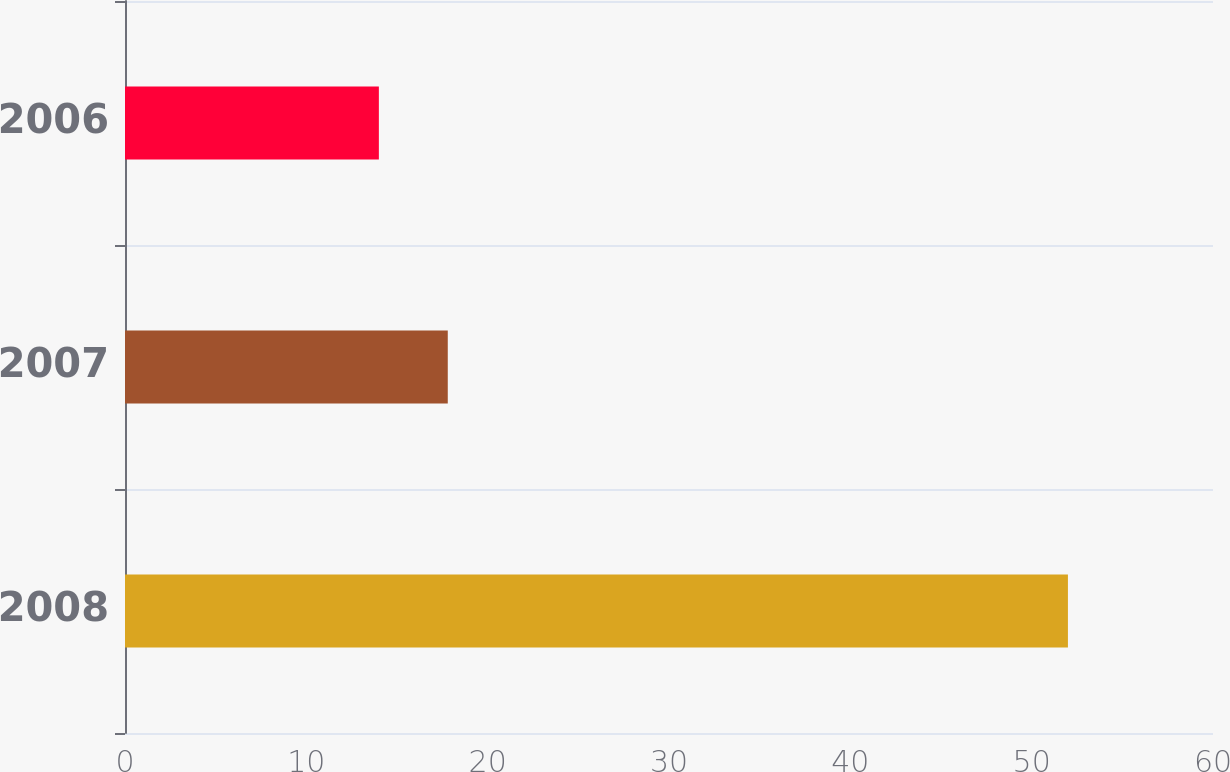Convert chart. <chart><loc_0><loc_0><loc_500><loc_500><bar_chart><fcel>2008<fcel>2007<fcel>2006<nl><fcel>52<fcel>17.8<fcel>14<nl></chart> 